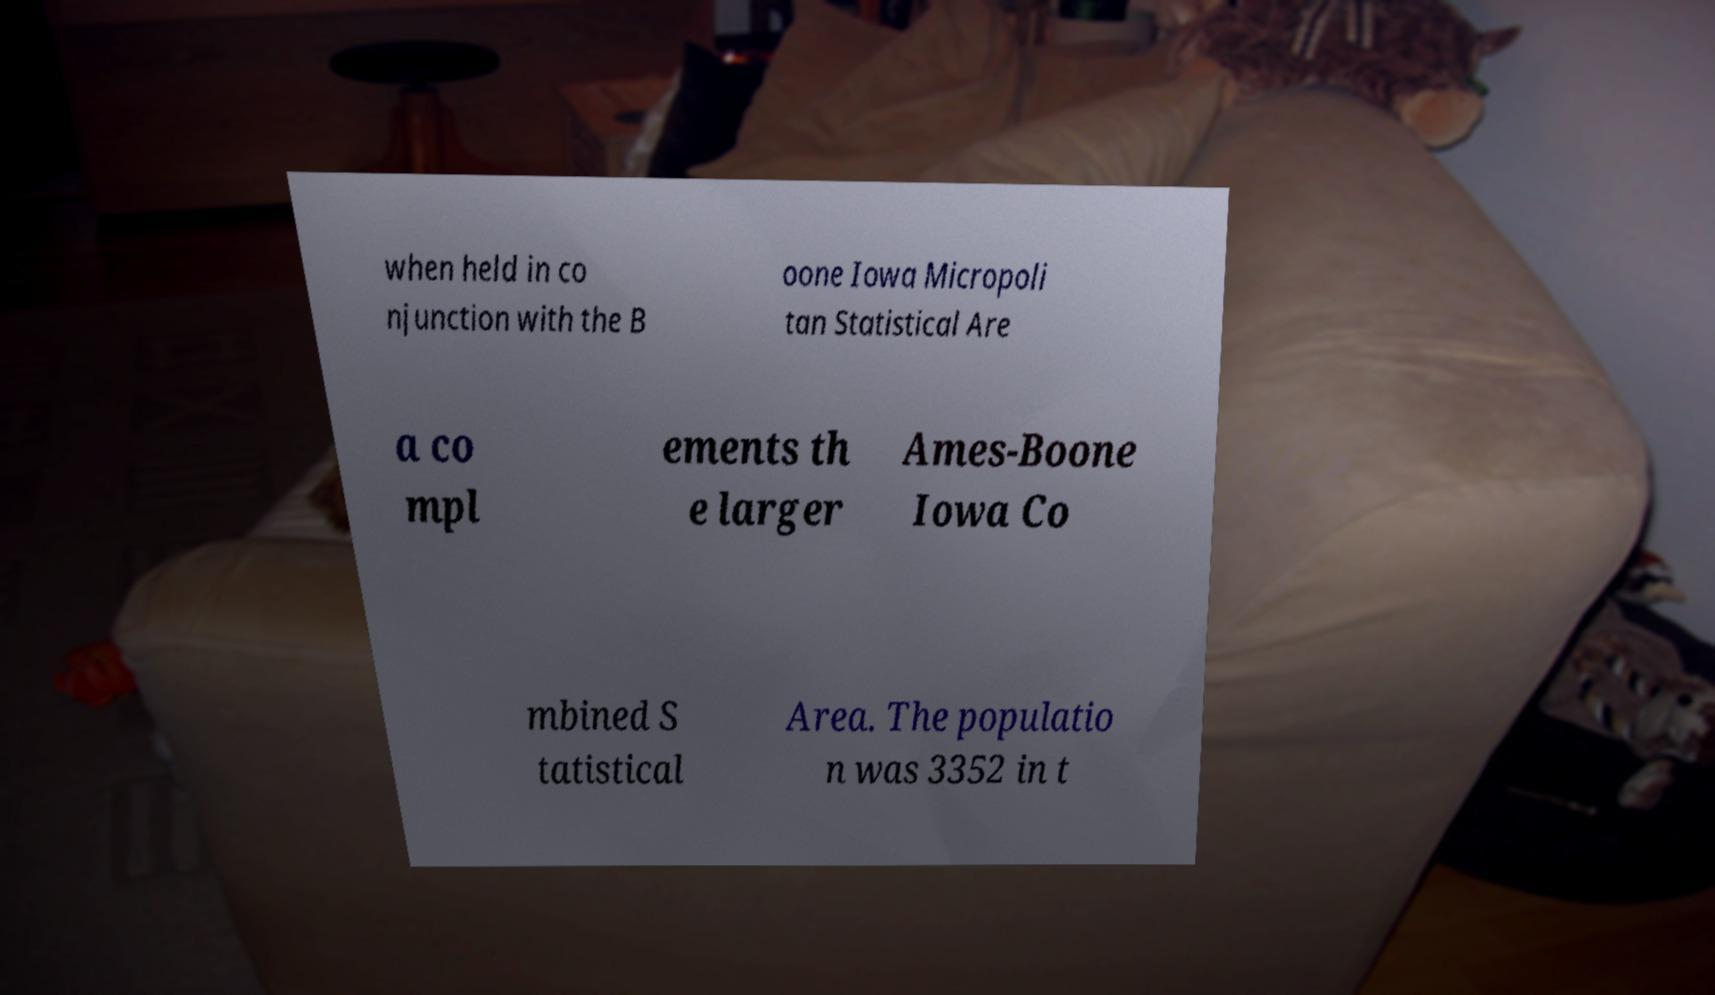For documentation purposes, I need the text within this image transcribed. Could you provide that? when held in co njunction with the B oone Iowa Micropoli tan Statistical Are a co mpl ements th e larger Ames-Boone Iowa Co mbined S tatistical Area. The populatio n was 3352 in t 